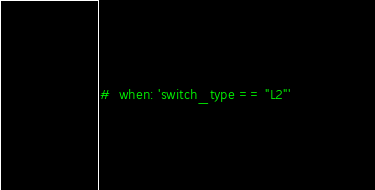Convert code to text. <code><loc_0><loc_0><loc_500><loc_500><_YAML_>#  when: 'switch_type == "L2"'
</code> 